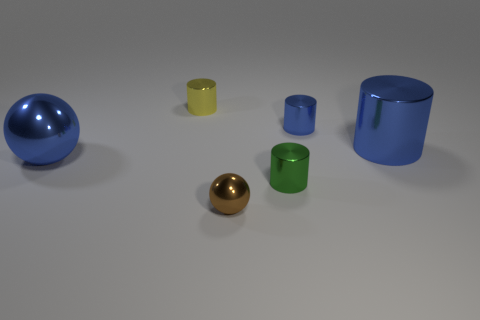Subtract 1 cylinders. How many cylinders are left? 3 Subtract all red cylinders. Subtract all purple balls. How many cylinders are left? 4 Add 1 purple metal cylinders. How many objects exist? 7 Subtract all spheres. How many objects are left? 4 Subtract 0 cyan cylinders. How many objects are left? 6 Subtract all large spheres. Subtract all tiny cylinders. How many objects are left? 2 Add 5 tiny yellow metallic things. How many tiny yellow metallic things are left? 6 Add 3 red shiny spheres. How many red shiny spheres exist? 3 